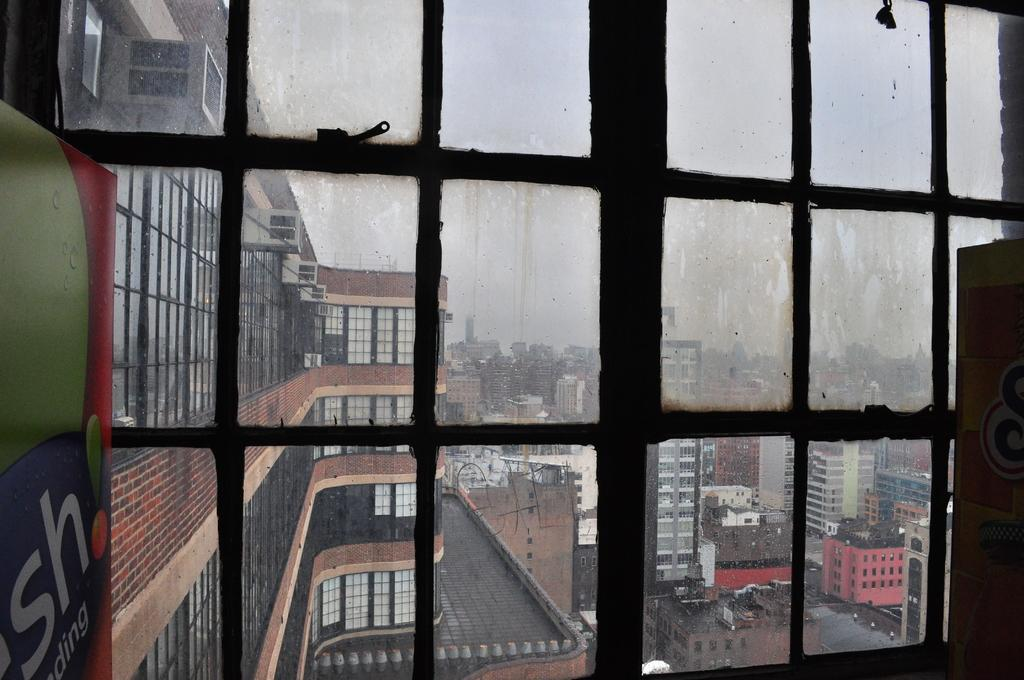What is present in the image that separates the inside from the outside? There is a window glass in the image. What can be seen outside the window glass? There are buildings visible outside the window glass. How many goats are visible outside the window glass? There are no goats visible outside the window glass in the image. What type of activity is the goat performing outside the window glass? There is no goat present in the image, so it is not possible to determine what activity it might be performing. 